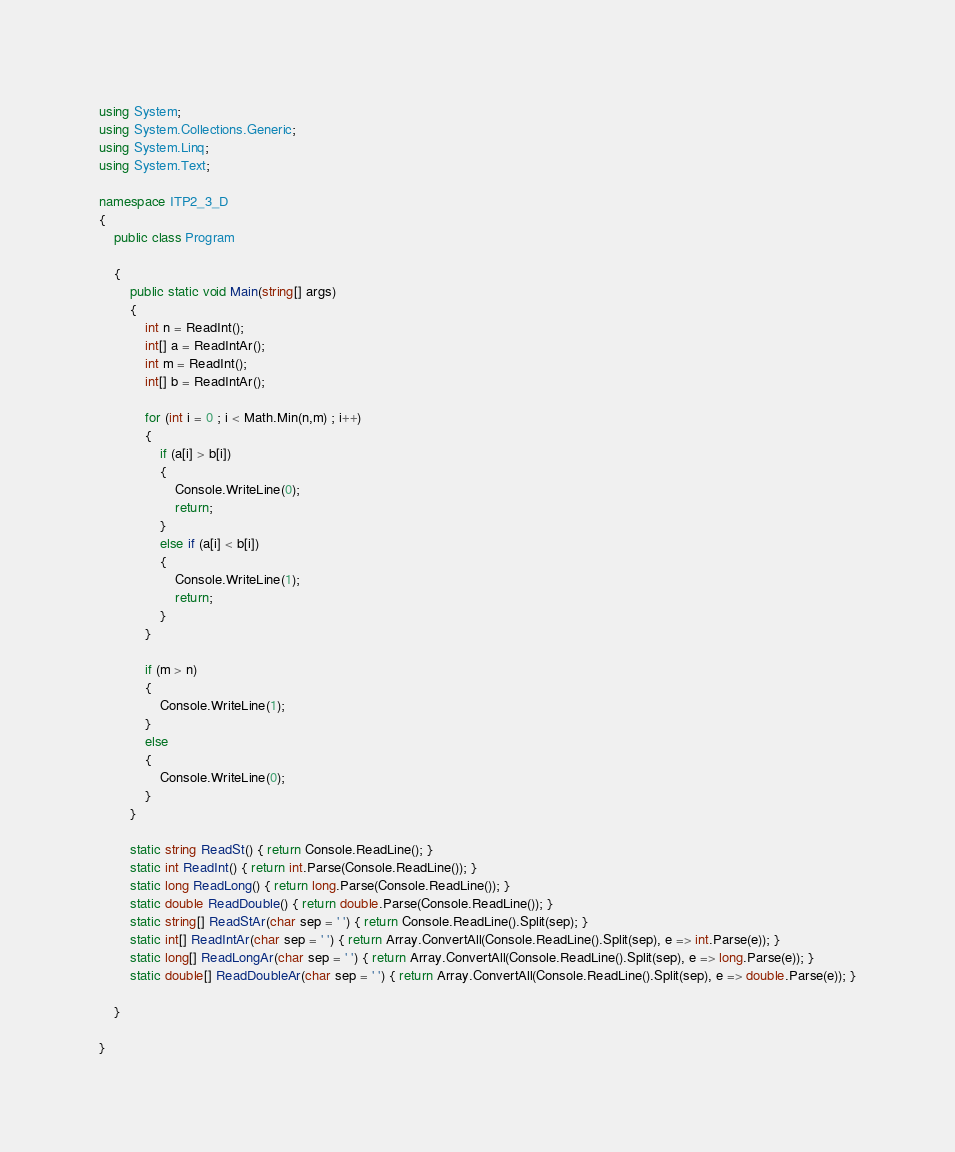Convert code to text. <code><loc_0><loc_0><loc_500><loc_500><_C#_>using System;
using System.Collections.Generic;
using System.Linq;
using System.Text;

namespace ITP2_3_D
{
    public class Program

    {
        public static void Main(string[] args)
        {
            int n = ReadInt();
            int[] a = ReadIntAr();
            int m = ReadInt();
            int[] b = ReadIntAr();

            for (int i = 0 ; i < Math.Min(n,m) ; i++)
            {
                if (a[i] > b[i])
                {
                    Console.WriteLine(0);
                    return;
                }
                else if (a[i] < b[i])
                {
                    Console.WriteLine(1);
                    return;
                }
            }

            if (m > n)
            {
                Console.WriteLine(1);
            }
            else
            {
                Console.WriteLine(0);
            }
        }

        static string ReadSt() { return Console.ReadLine(); }
        static int ReadInt() { return int.Parse(Console.ReadLine()); }
        static long ReadLong() { return long.Parse(Console.ReadLine()); }
        static double ReadDouble() { return double.Parse(Console.ReadLine()); }
        static string[] ReadStAr(char sep = ' ') { return Console.ReadLine().Split(sep); }
        static int[] ReadIntAr(char sep = ' ') { return Array.ConvertAll(Console.ReadLine().Split(sep), e => int.Parse(e)); }
        static long[] ReadLongAr(char sep = ' ') { return Array.ConvertAll(Console.ReadLine().Split(sep), e => long.Parse(e)); }
        static double[] ReadDoubleAr(char sep = ' ') { return Array.ConvertAll(Console.ReadLine().Split(sep), e => double.Parse(e)); }

    }

}

</code> 